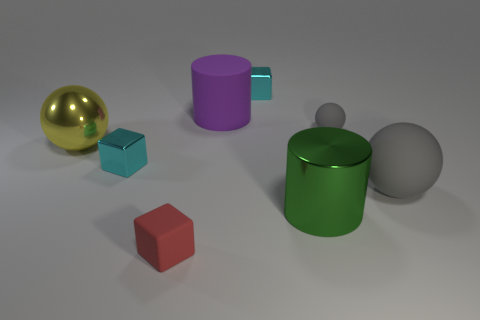There is a big cylinder that is made of the same material as the big gray ball; what color is it?
Provide a succinct answer. Purple. What is the shape of the big rubber object that is the same color as the small ball?
Your answer should be very brief. Sphere. Are there an equal number of big green metallic things behind the small red object and small matte objects to the left of the big purple object?
Your response must be concise. Yes. The small cyan object that is behind the small matte object behind the tiny rubber cube is what shape?
Give a very brief answer. Cube. What material is the other big object that is the same shape as the purple thing?
Offer a terse response. Metal. There is a sphere that is the same size as the red rubber block; what color is it?
Provide a short and direct response. Gray. Is the number of small cyan blocks right of the purple cylinder the same as the number of large matte cubes?
Give a very brief answer. No. There is a big matte thing right of the tiny cube behind the small gray ball; what is its color?
Your answer should be very brief. Gray. There is a metal thing in front of the small metallic block in front of the big yellow object; what size is it?
Your answer should be compact. Large. The other sphere that is the same color as the small matte ball is what size?
Offer a very short reply. Large. 